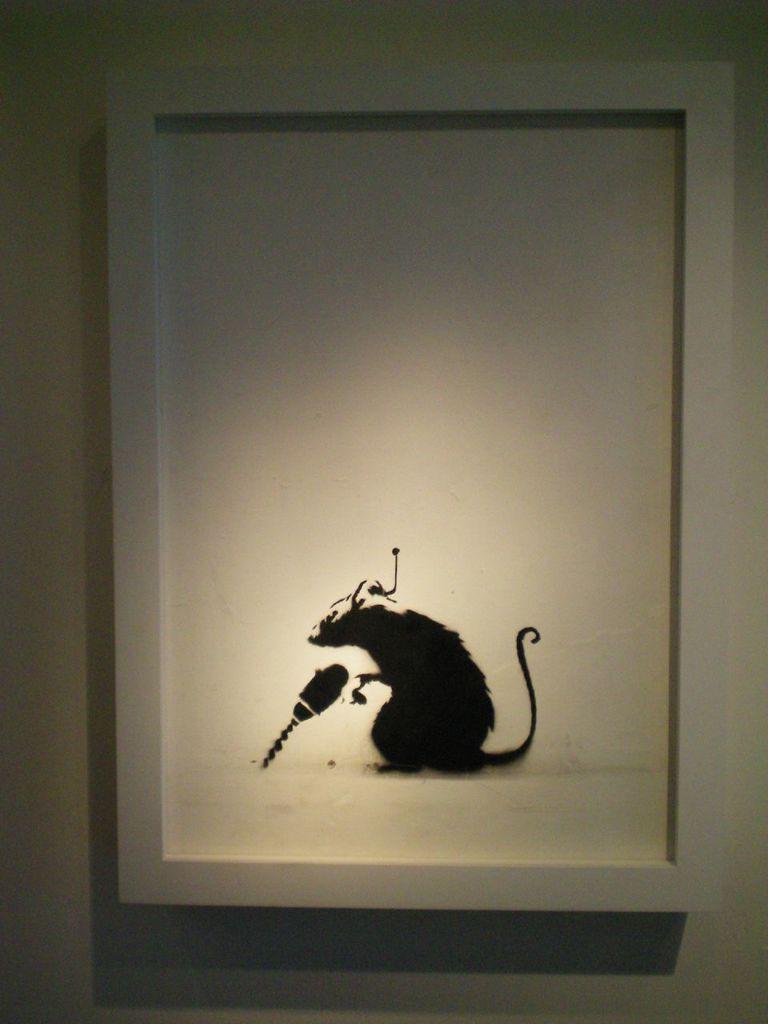Describe this image in one or two sentences. In this image we can see the photo frame on a wall containing the picture of a rat on it. 